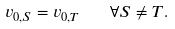Convert formula to latex. <formula><loc_0><loc_0><loc_500><loc_500>v _ { 0 , S } = v _ { 0 , T } \quad \forall S \neq T .</formula> 